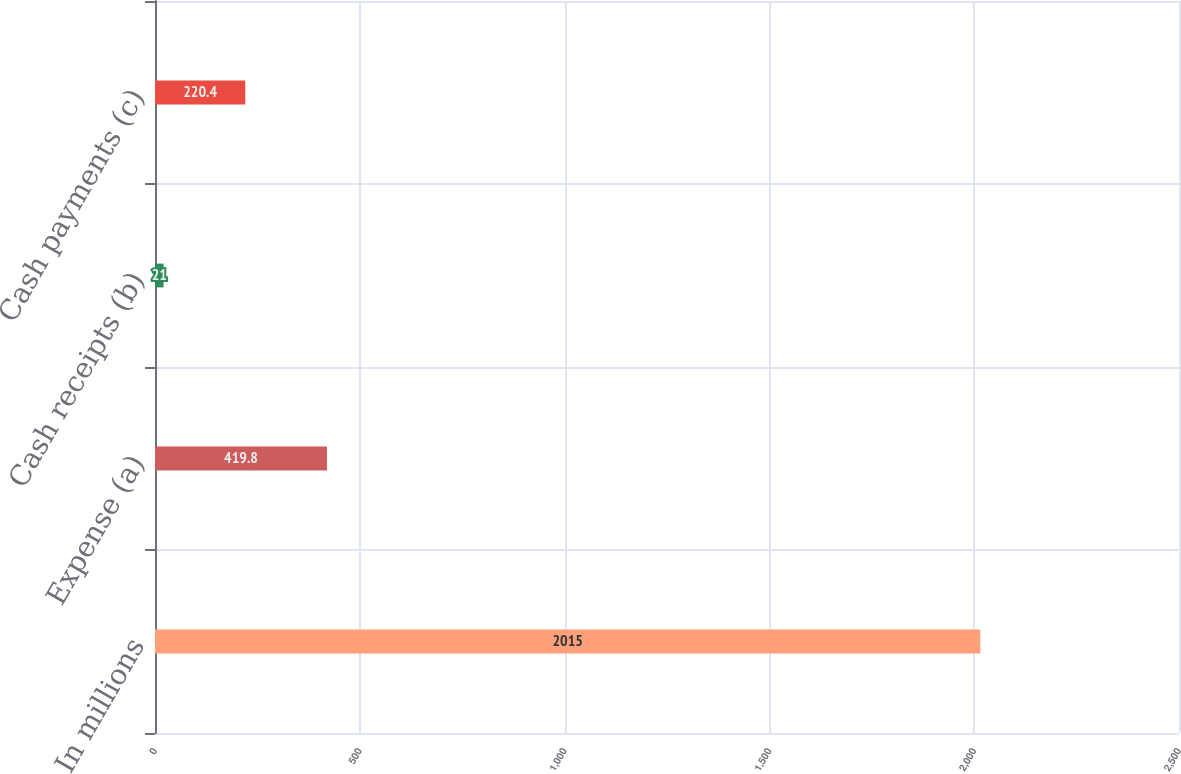Convert chart. <chart><loc_0><loc_0><loc_500><loc_500><bar_chart><fcel>In millions<fcel>Expense (a)<fcel>Cash receipts (b)<fcel>Cash payments (c)<nl><fcel>2015<fcel>419.8<fcel>21<fcel>220.4<nl></chart> 